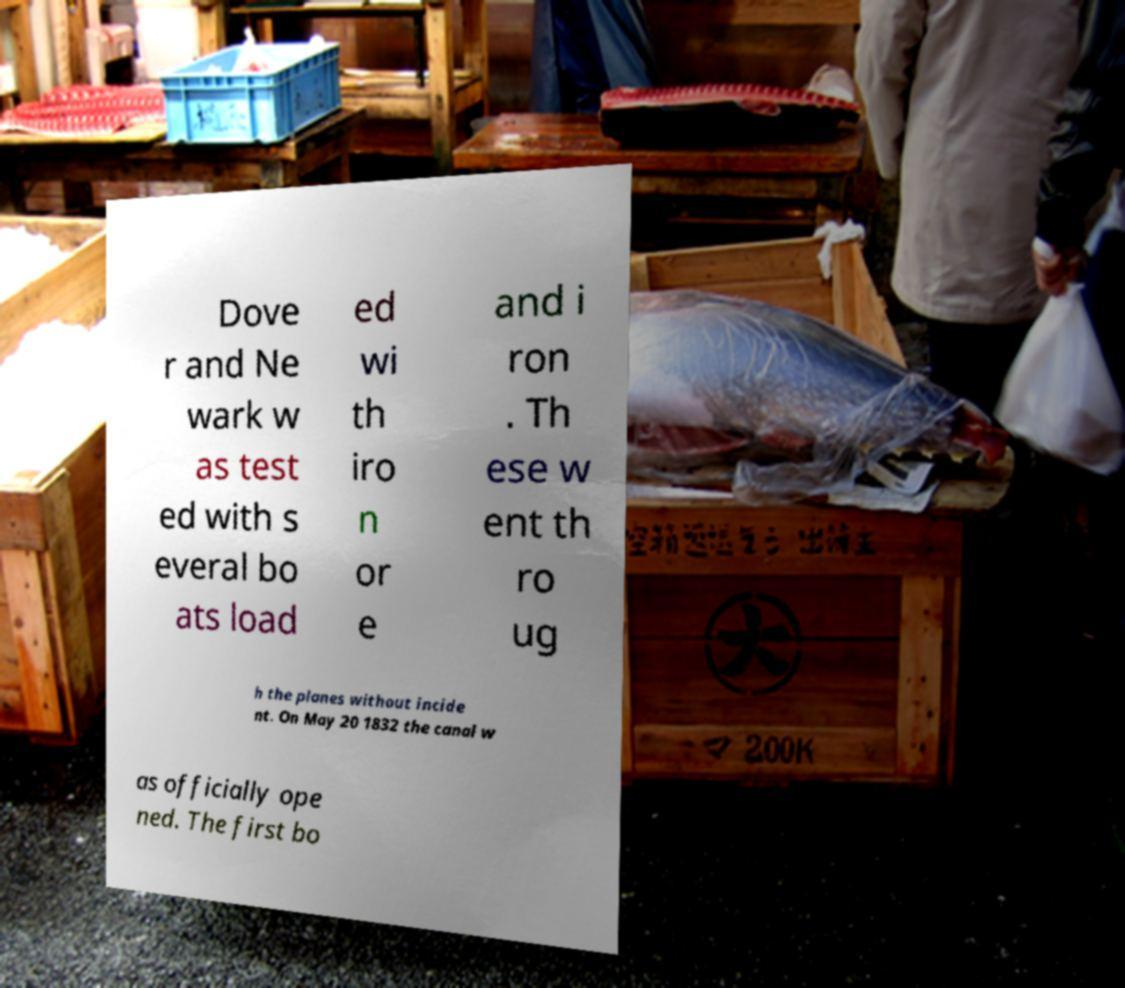For documentation purposes, I need the text within this image transcribed. Could you provide that? Dove r and Ne wark w as test ed with s everal bo ats load ed wi th iro n or e and i ron . Th ese w ent th ro ug h the planes without incide nt. On May 20 1832 the canal w as officially ope ned. The first bo 